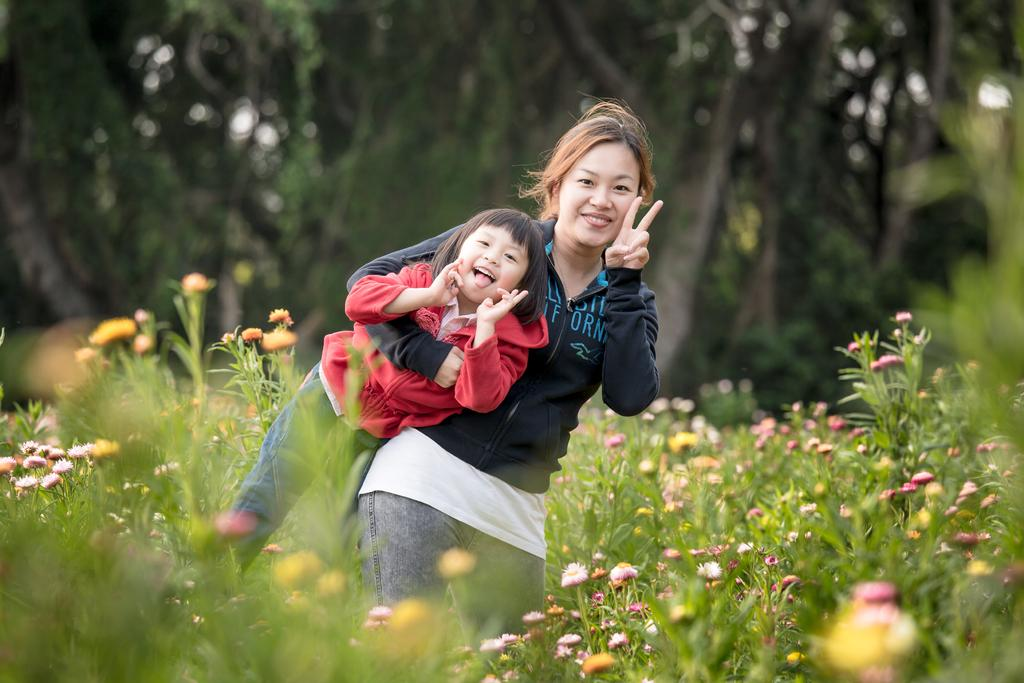What is happening in the center of the image? There is a lady holding a girl in the center of the image. What can be seen at the bottom of the image? There are plants with flowers at the bottom of the image. What is visible in the background of the image? There are trees in the background of the image. How many pizzas are being served by the army in the image? There is no mention of pizzas or the army in the image. The image features a lady holding a girl, plants with flowers, and trees in the background. 